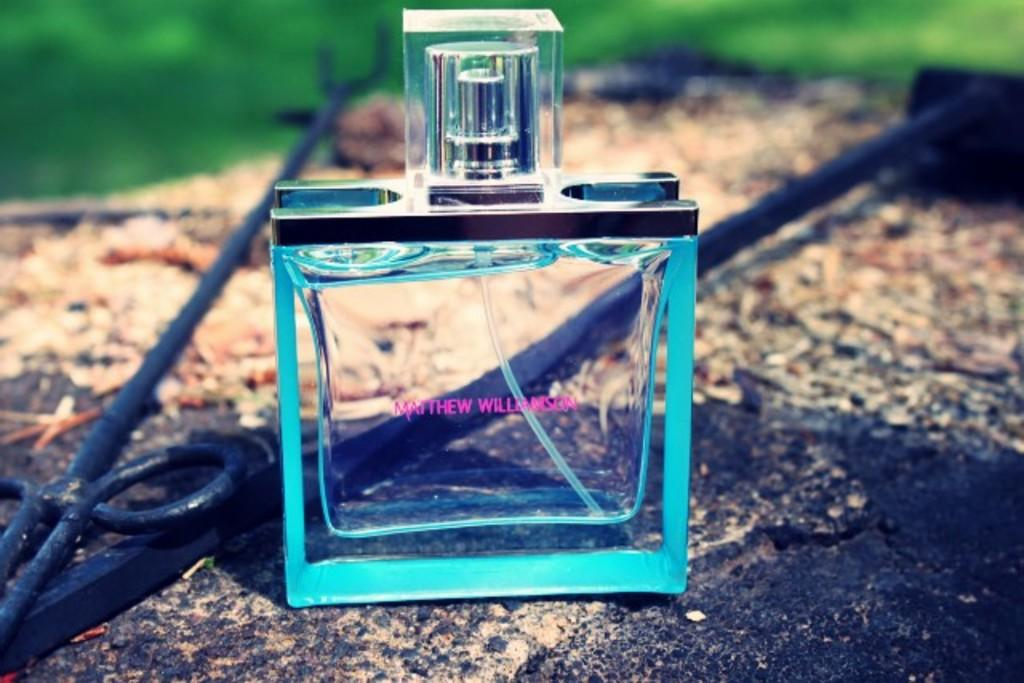<image>
Relay a brief, clear account of the picture shown. Clear bottle of Matthew Williamson with a square cap. 